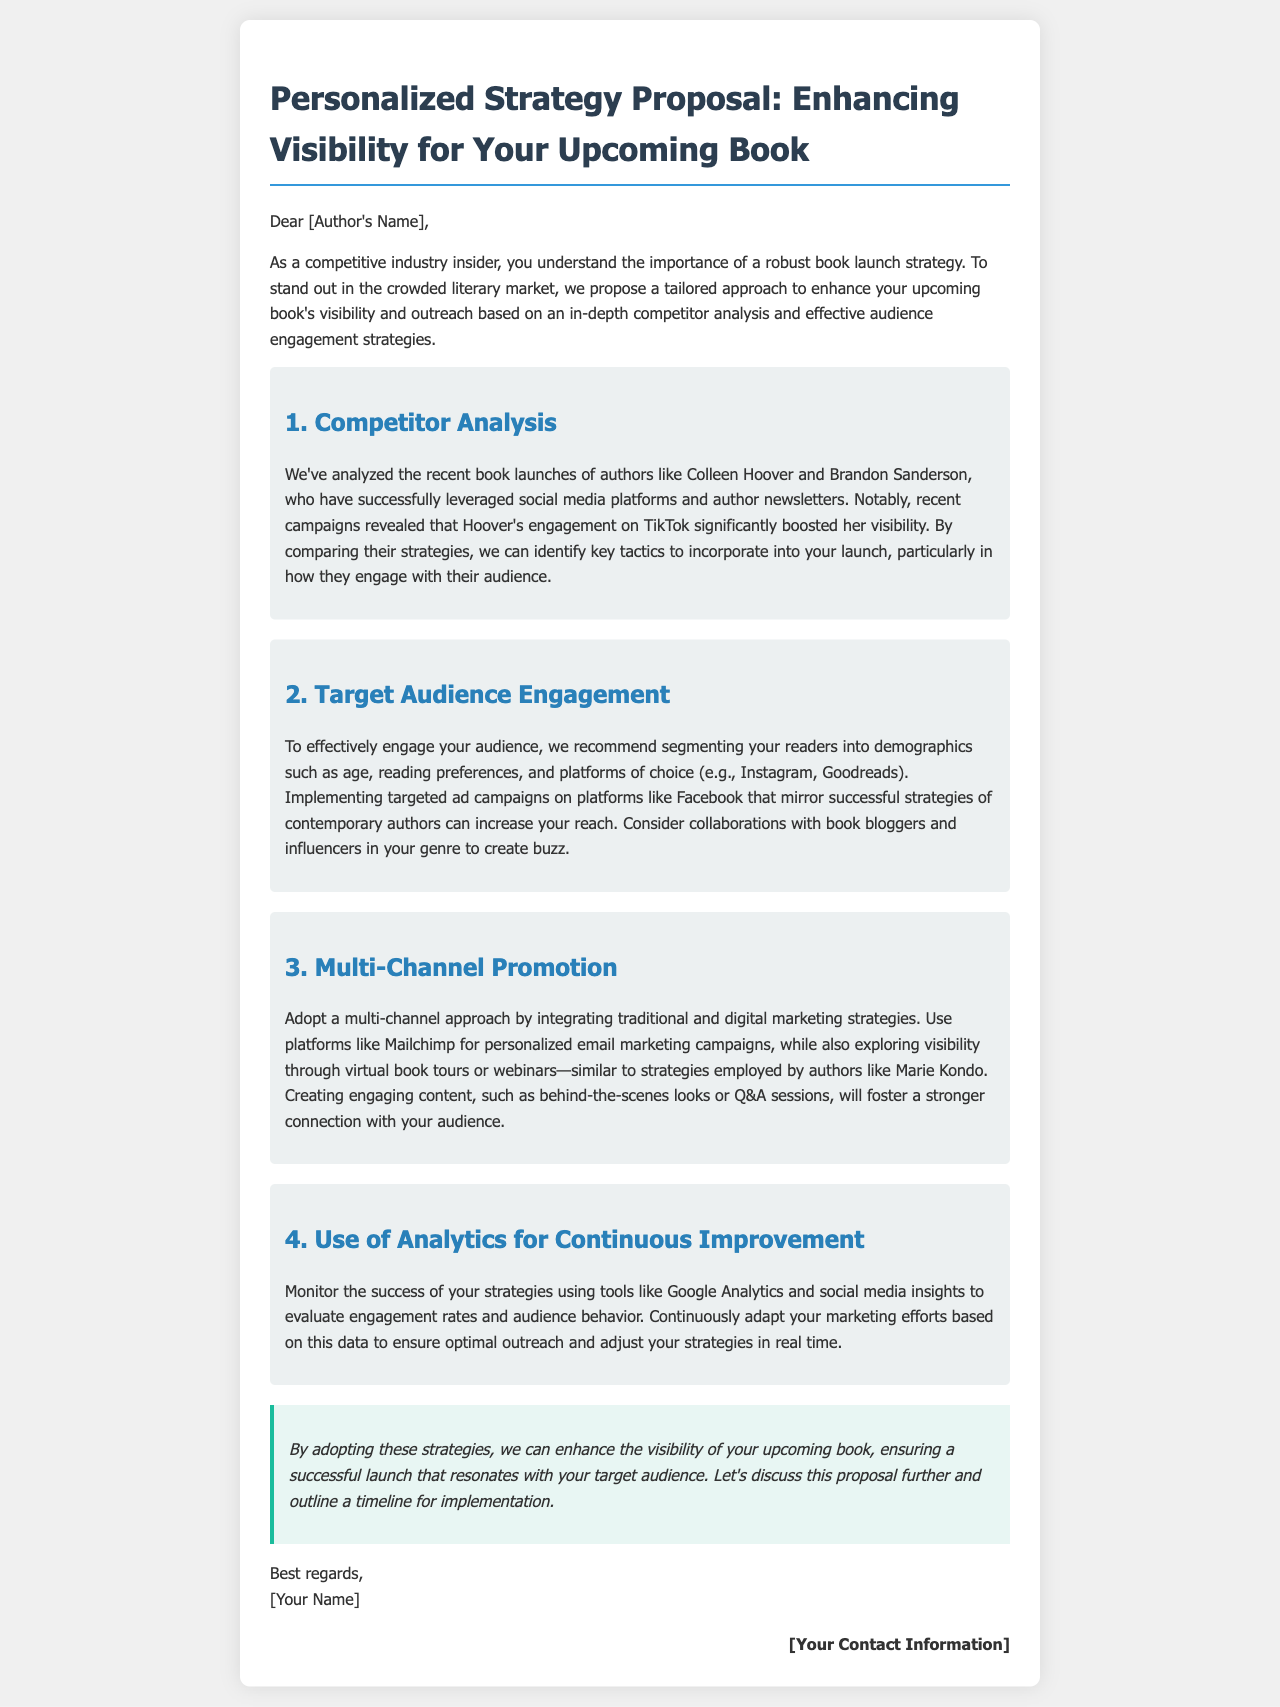What is the subject of the proposal? The subject of the proposal concerns enhancing visibility for an upcoming book.
Answer: Enhancing visibility for your upcoming book Who are two authors mentioned in the competitor analysis? The document states that Colleen Hoover and Brandon Sanderson are analyzed.
Answer: Colleen Hoover and Brandon Sanderson Which platform significantly boosted Hoover's visibility? The document mentions that engagement on TikTok boosted her visibility.
Answer: TikTok What is one recommended platform for targeted ad campaigns? Facebook is suggested as a platform for targeted ad campaigns.
Answer: Facebook What tool is suggested for monitoring success? Google Analytics is mentioned as a tool for monitoring the success of strategies.
Answer: Google Analytics What type of approach is proposed for promotion? A multi-channel approach integrating both traditional and digital marketing strategies is proposed.
Answer: Multi-channel approach What is the final call to action in the proposal? The document suggests discussing the proposal further and outlining a timeline for implementation.
Answer: Discuss this proposal further Who is the proposal addressed to? The proposal is addressed to "[Author's Name]."
Answer: [Author's Name] 